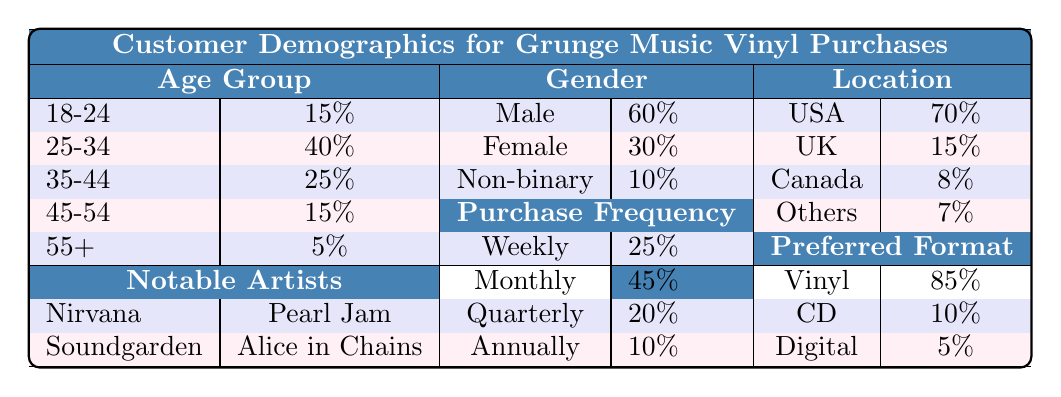What percentage of customers are aged 25-34? The table lists the percentage of customers in each age group. For the age group 25-34, the percentage is 40%.
Answer: 40% What is the total percentage of female and non-binary customers? The table shows that female customers make up 30% and non-binary customers 10%. Adding these together: 30% + 10% = 40%.
Answer: 40% Which age group has the highest percentage of customers? By reviewing the age percentages, 25-34 has the highest percentage at 40%.
Answer: 25-34 What is the average age group percentage among all age categories? The percentages for each age group are 15%, 40%, 25%, 15%, and 5%. To find the average: (15 + 40 + 25 + 15 + 5) / 5 = 100 / 5 = 20%.
Answer: 20% Is the majority of customers male? The table indicates that 60% of customers are male, which is the majority as it exceeds 50%.
Answer: Yes What location has the highest percentage of customers? According to the data, 70% of customers are located in the USA, which is higher than any other location percentage listed.
Answer: USA If the purchase frequency for monthly customers is increased by 5%, what will be their new percentage? The current percentage for monthly customers is 45%. Increasing it by 5% results in 45% + 5% = 50%.
Answer: 50% How many more vinyl customers are there compared to digital format customers? Vinyl customers make up 85%, whereas digital format customers represent 5%. The difference is 85% - 5% = 80%.
Answer: 80% What is the percentage of customers who prefer formats other than vinyl? Adding the percentages of CD (10%) and digital (5%) gives us 10% + 5% = 15%. Thus, 15% prefer formats other than vinyl.
Answer: 15% Which gender has the lowest percentage among customers? The table indicates non-binary customers at 10%, which is less than both male (60%) and female (30%) percentages.
Answer: Non-binary 